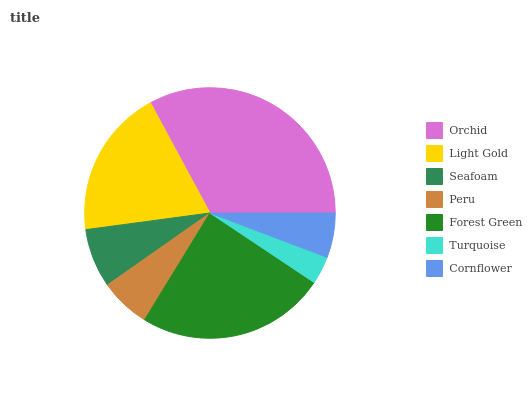Is Turquoise the minimum?
Answer yes or no. Yes. Is Orchid the maximum?
Answer yes or no. Yes. Is Light Gold the minimum?
Answer yes or no. No. Is Light Gold the maximum?
Answer yes or no. No. Is Orchid greater than Light Gold?
Answer yes or no. Yes. Is Light Gold less than Orchid?
Answer yes or no. Yes. Is Light Gold greater than Orchid?
Answer yes or no. No. Is Orchid less than Light Gold?
Answer yes or no. No. Is Seafoam the high median?
Answer yes or no. Yes. Is Seafoam the low median?
Answer yes or no. Yes. Is Orchid the high median?
Answer yes or no. No. Is Cornflower the low median?
Answer yes or no. No. 